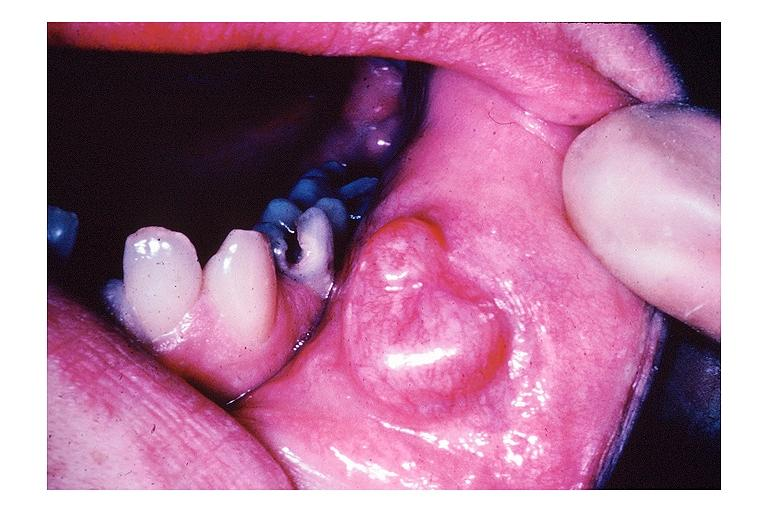does this image show mucocele?
Answer the question using a single word or phrase. Yes 